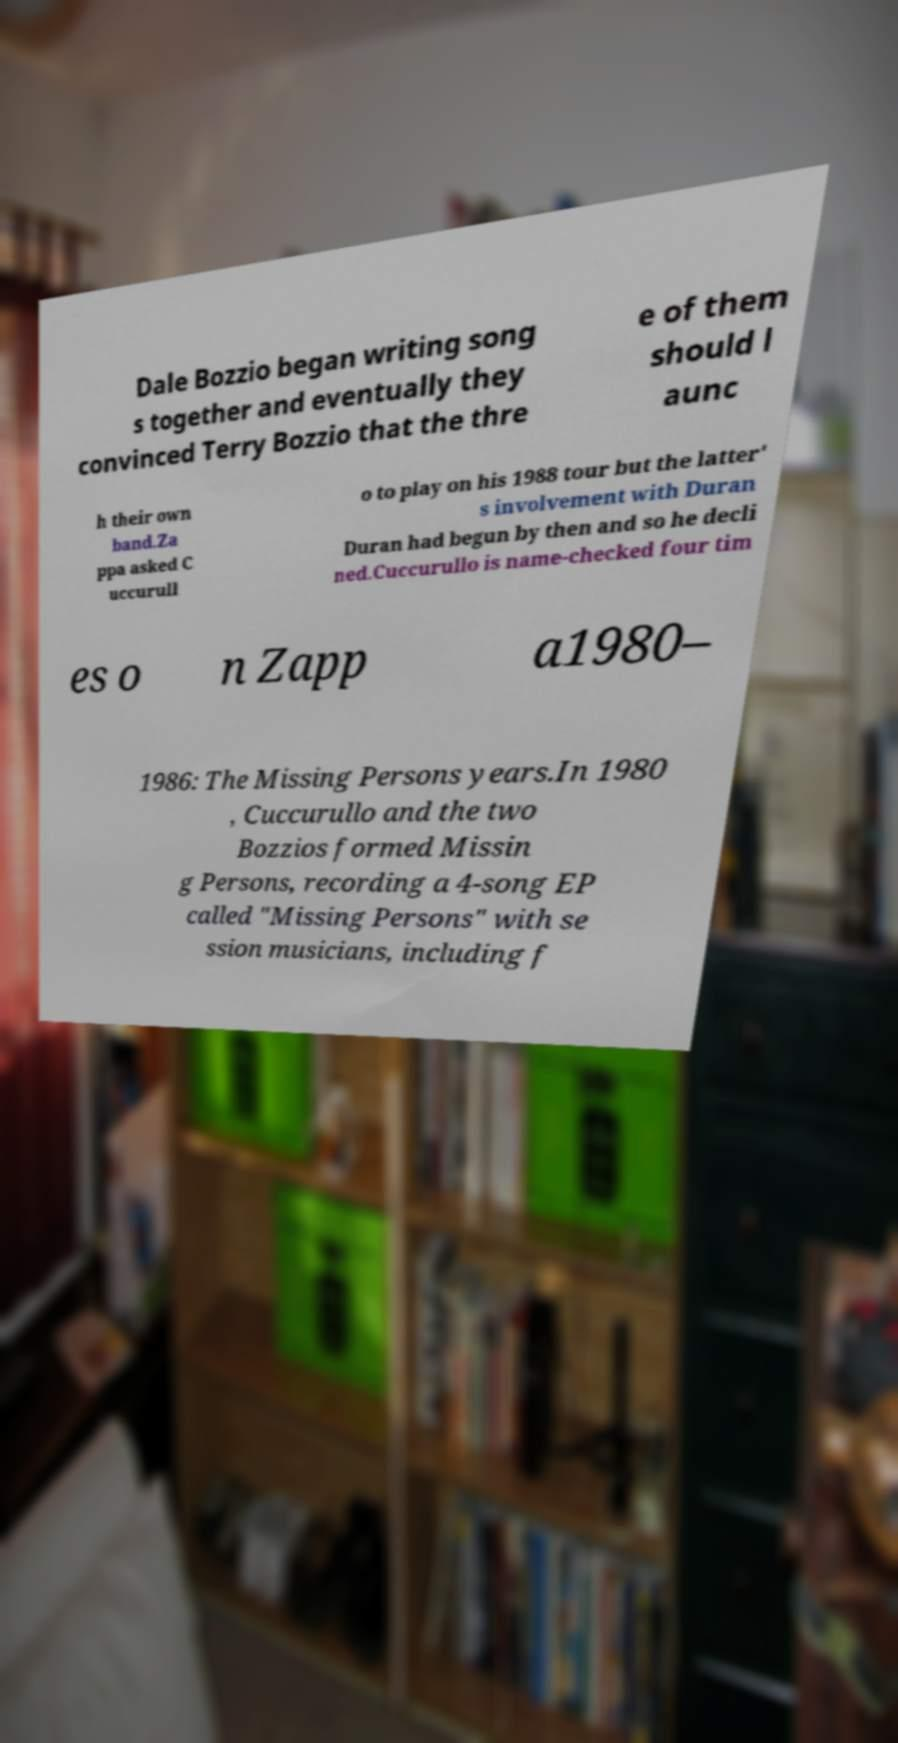There's text embedded in this image that I need extracted. Can you transcribe it verbatim? Dale Bozzio began writing song s together and eventually they convinced Terry Bozzio that the thre e of them should l aunc h their own band.Za ppa asked C uccurull o to play on his 1988 tour but the latter' s involvement with Duran Duran had begun by then and so he decli ned.Cuccurullo is name-checked four tim es o n Zapp a1980– 1986: The Missing Persons years.In 1980 , Cuccurullo and the two Bozzios formed Missin g Persons, recording a 4-song EP called "Missing Persons" with se ssion musicians, including f 